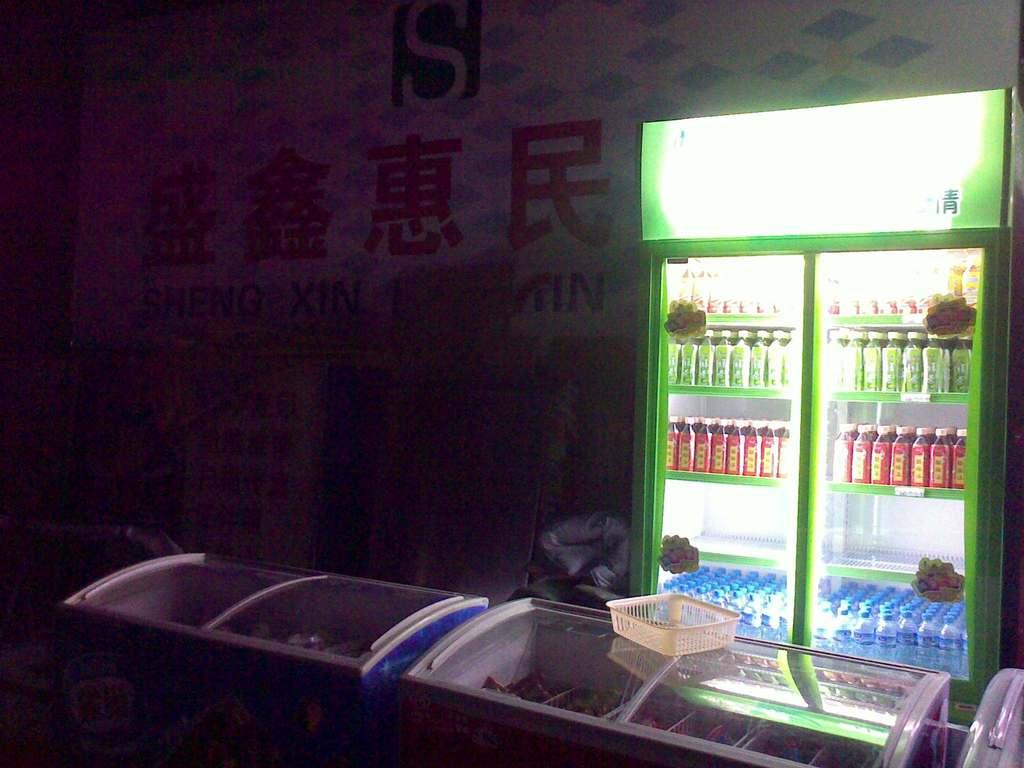What is the letter on the top of the wall?
Keep it short and to the point. S. 